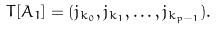<formula> <loc_0><loc_0><loc_500><loc_500>T [ A _ { 1 } ] = ( j _ { k _ { 0 } } , j _ { k _ { 1 } } , \dots , j _ { k _ { p - 1 } } ) .</formula> 